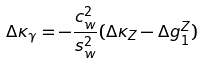Convert formula to latex. <formula><loc_0><loc_0><loc_500><loc_500>\Delta \kappa _ { \gamma } = - \frac { c _ { w } ^ { 2 } } { s _ { w } ^ { 2 } } ( \Delta \kappa _ { Z } - \Delta g _ { 1 } ^ { Z } )</formula> 